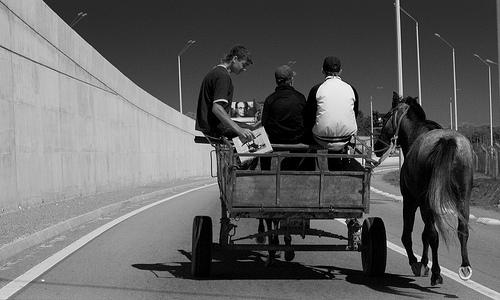What is one of the people in the wagon holding and what is the orientation of the person's head? One person is holding a magazine with their hand, and the head of the man holding it is looking down. Describe the attire of someone in the image and give a detail about their head. A man is dressed in casual clothing while wearing a baseball cap on his head, which has a regular-shaped brim. Name two things that are seen on the street and describe their appearance. White lines on the street appear spaced and parallel, and a street light over the street has a regular shape and shines from the distance. List three objects that are on or attached to the moving horse. A trotting horse has a metal shoe on its hoof, a rope nearby for guidance or control, and a long silky tail at the back. Mention an object that appears to be interacting with the horse and describe its location. A rope on the wagon, located not too far from the horse, could be used to guide or control it. What type of horse is seen in the image and mention a physical feature of the horse? A trotting horse is walking on the road, characterized by a long silky tail and a metal shoe on its hoof. Describe any notable objects under the wagon. There are black rubber wheels, and possibly parts of a shade and a curving wall beside could be a reflection or shadow. How many people are in the wagon and what are they doing? There are three people in the wagon, enjoying their evening, and riding together down the road in a horse-drawn vehicle. What obstacle might be casting a shadow on the ground and give details about the shape and size of it? The wagon, horse, or nearby objects might be casting a shadow on the ground, resulting in an elongated and irregular shape encompassing considerable area. What type of vehicle is seen in the image including its locomotive source? A horse-drawn wagon, which is a cart being pulled by a walking horse. Is the cart being pulled by a dog instead of a horse? No, it's not mentioned in the image. What's the paper in the boy's hand called? A magazine. Choose the correct description for the scene: A)A horse racing beside a car B)People riding bicycles next to a train C)People riding in a wagon pulled by a horse C)People riding in a wagon pulled by a horse. Describe the location of the street light. Above the street at a distance. What are the people riding in the image? People are riding in a wagon. Who is looking down in the image? A man wearing a baseball cap. What's visible on the horse's hoof? A metal horse shoe. From the given options, what is the wagon moving down? a) a road b) a mountain c) a river a) a road. What type of vehicle are the people riding in? A horse-drawn cart. Choose the right option for the location of the wheels in the image - a)Back of the trailer b)Under the trailer c)Front of the trailer b)Under the trailer. What item can be observed on the horse's backside? A long silky tail. What type of surface is the wagon and horse moving? Road. How many wheels are under the trailer? Two. What kind of animal is walking beside the vehicle? A horse. Find the expression of the person with the baseball cap. The person's head is looking down. How many people are in the vehicle? Three. What is the horse doing on the street? Walking. What are the white lines on? The street. 